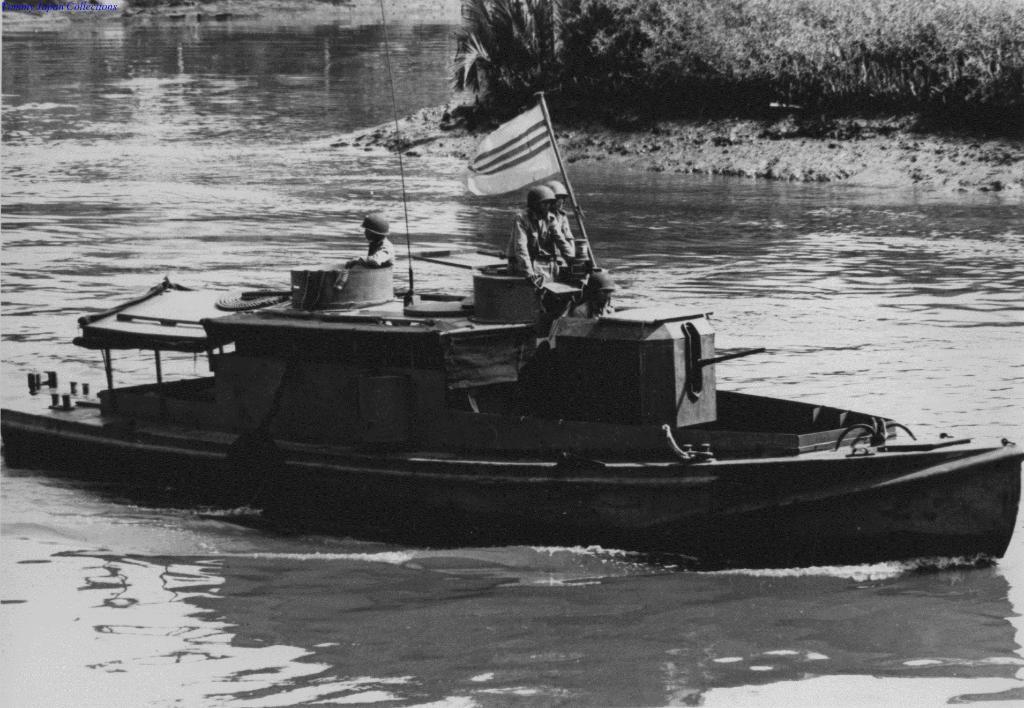How would you summarize this image in a sentence or two? In the foreground I can see three persons on a boat in the water and flag pole. In the background I can see grass, trees and so on. This image is taken may be in the lake. 